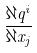<formula> <loc_0><loc_0><loc_500><loc_500>\frac { \partial q ^ { i } } { \partial x _ { j } }</formula> 